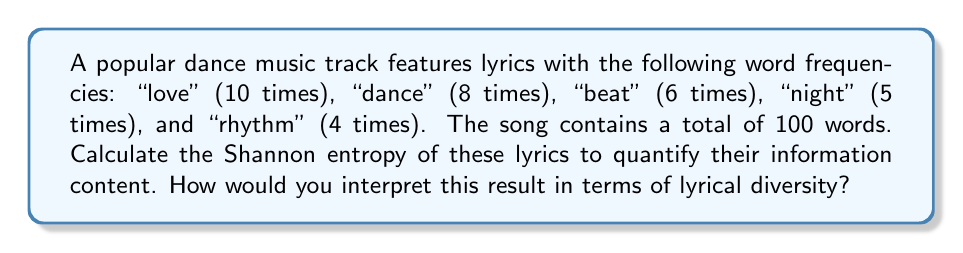Can you solve this math problem? To calculate the Shannon entropy of the lyrics, we'll follow these steps:

1) First, we need to calculate the probability of each word occurring:

   $p(\text{love}) = 10/100 = 0.1$
   $p(\text{dance}) = 8/100 = 0.08$
   $p(\text{beat}) = 6/100 = 0.06$
   $p(\text{night}) = 5/100 = 0.05$
   $p(\text{rhythm}) = 4/100 = 0.04$
   $p(\text{other words}) = 67/100 = 0.67$

2) The Shannon entropy is calculated using the formula:

   $$H = -\sum_{i=1}^n p_i \log_2(p_i)$$

   where $p_i$ is the probability of each word or category.

3) Let's calculate each term:

   $-0.1 \log_2(0.1) \approx 0.332$
   $-0.08 \log_2(0.08) \approx 0.292$
   $-0.06 \log_2(0.06) \approx 0.244$
   $-0.05 \log_2(0.05) \approx 0.216$
   $-0.04 \log_2(0.04) \approx 0.186$
   $-0.67 \log_2(0.67) \approx 0.390$

4) Sum all these terms:

   $H = 0.332 + 0.292 + 0.244 + 0.216 + 0.186 + 0.390 = 1.660$ bits

5) Interpretation: The maximum entropy for a vocabulary of 6 categories (5 specific words + others) would be $\log_2(6) \approx 2.585$ bits. Our calculated entropy of 1.660 bits is about 64% of this maximum, indicating a moderate level of lyrical diversity. While there is some repetition of key words (as expected in dance music), there's still a significant amount of variation in the lyrics.
Answer: 1.660 bits 